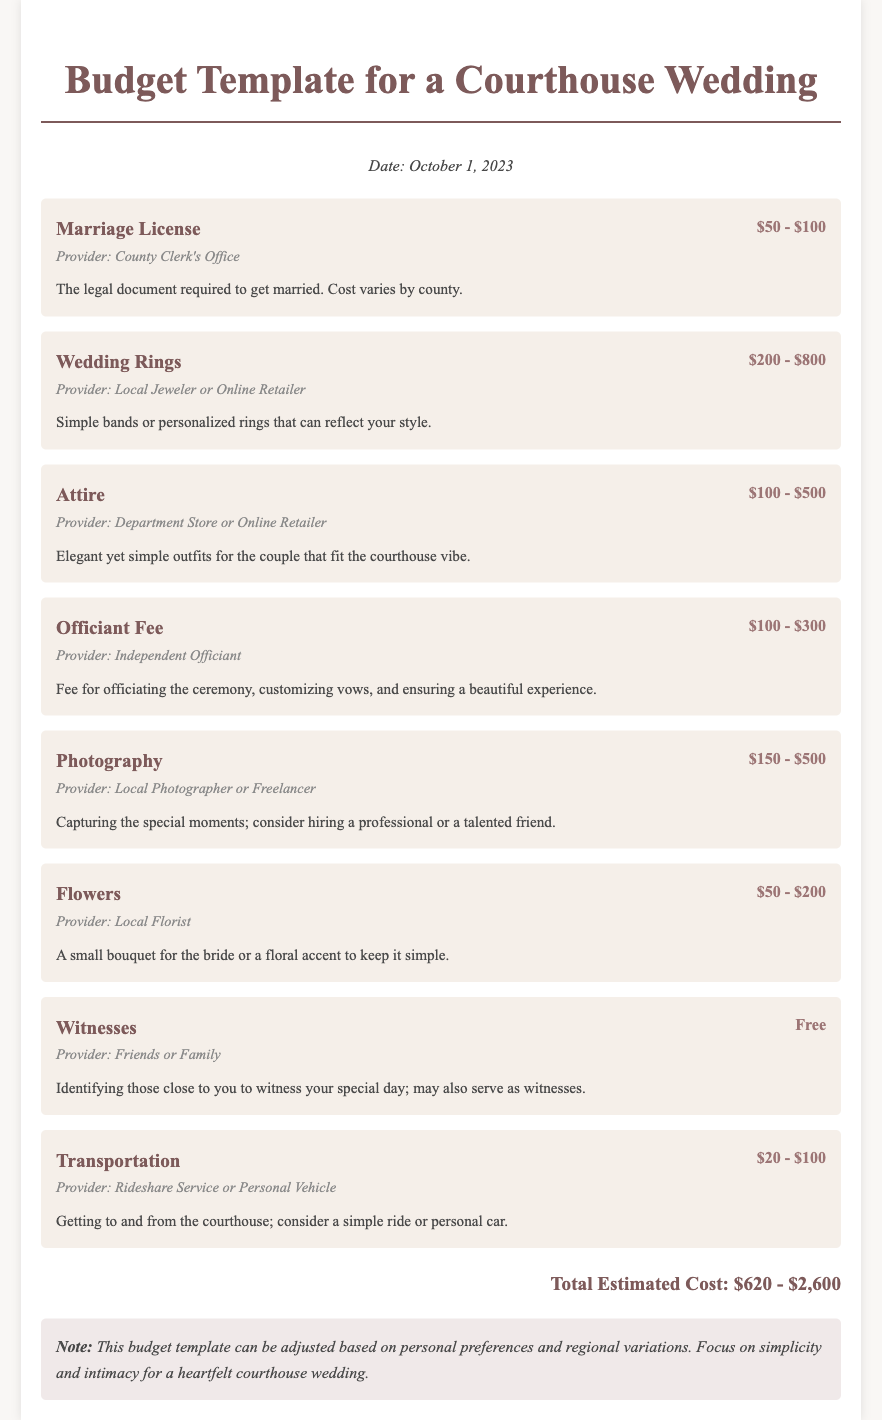What is the estimated cost range for a marriage license? The document specifies that the cost range for a marriage license is between $50 and $100.
Answer: $50 - $100 What is the typical cost range for wedding rings? The document indicates that wedding rings typically cost between $200 and $800.
Answer: $200 - $800 Who provides the marriage license? The document states that the marriage license is provided by the County Clerk's Office.
Answer: County Clerk's Office What is the total estimated cost range for the budget? The total estimated cost range is calculated from the sum of all budget items, which is $620 to $2,600.
Answer: $620 - $2,600 What item is marked as free in the budget? The budget lists witnesses as the item that is free.
Answer: Free What does the budget item for attire specify? The budget item for attire specifies it costs between $100 and $500.
Answer: $100 - $500 How much does photography typically cost? According to the document, photography costs between $150 and $500.
Answer: $150 - $500 What does the note at the end suggest focusing on? The note suggests focusing on simplicity and intimacy for a heartfelt courthouse wedding.
Answer: Simplicity and intimacy 